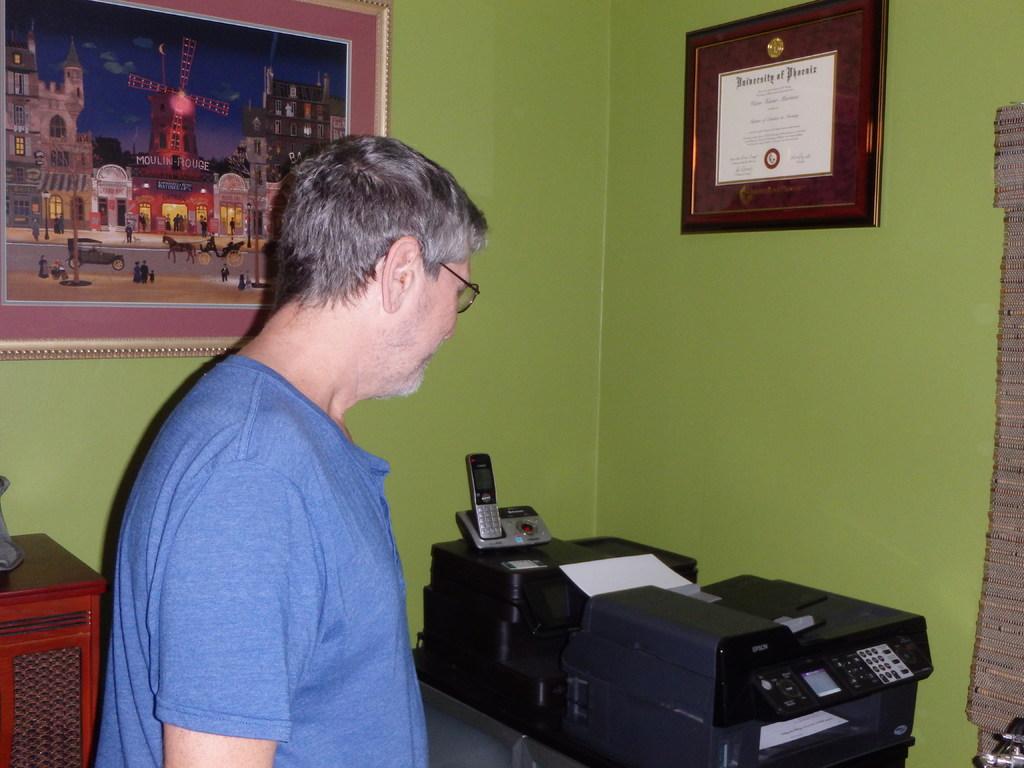What university is the diploma from?
Your answer should be compact. University of phoenix. What does the other text on the diploma say?
Offer a terse response. University of phoenix. 